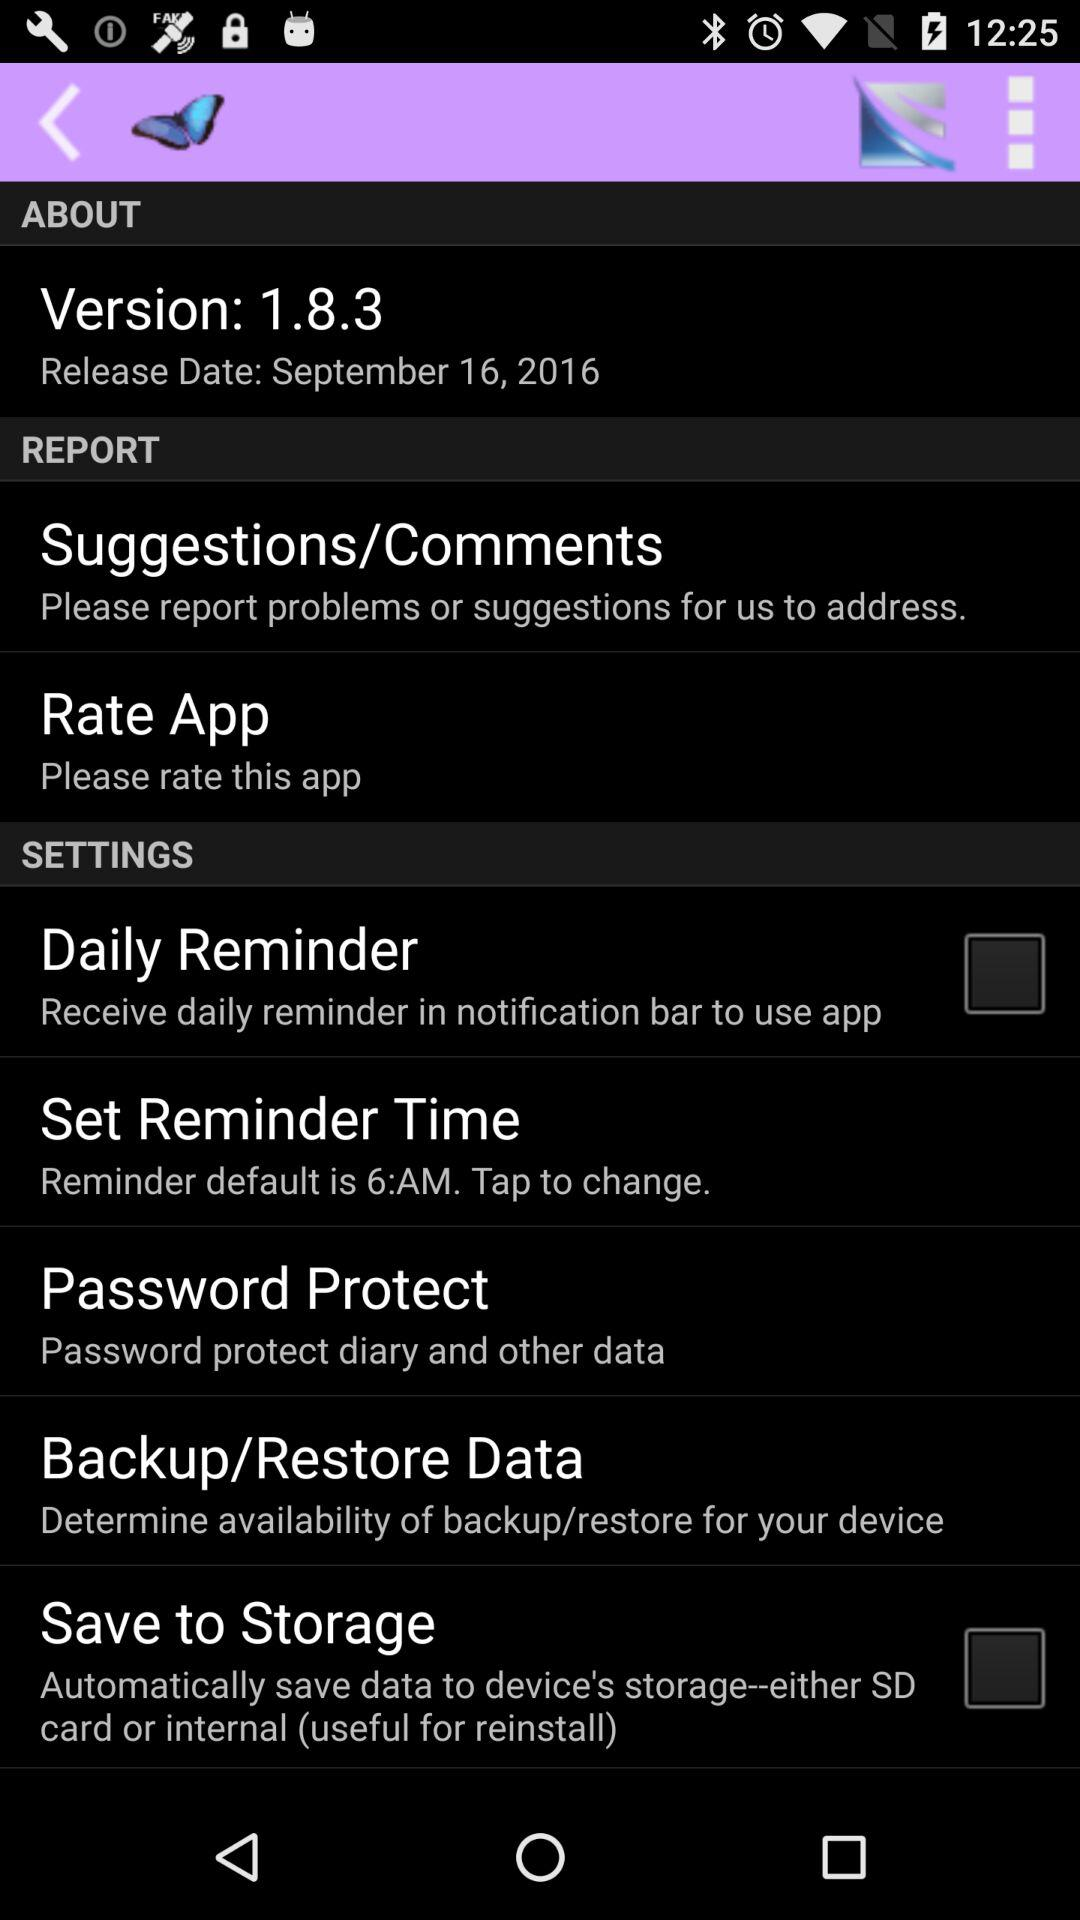What is the default time for "Reminder"? The default time for "Reminder" is 6 AM. 